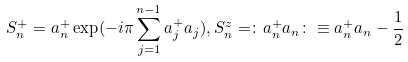<formula> <loc_0><loc_0><loc_500><loc_500>S ^ { + } _ { n } = a ^ { + } _ { n } \exp ( - i \pi \sum _ { j = 1 } ^ { n - 1 } a ^ { + } _ { j } a _ { j } ) , S ^ { z } _ { n } = \colon a ^ { + } _ { n } a _ { n } \colon \equiv a ^ { + } _ { n } a _ { n } - \frac { 1 } { 2 }</formula> 